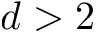<formula> <loc_0><loc_0><loc_500><loc_500>d > 2</formula> 